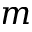<formula> <loc_0><loc_0><loc_500><loc_500>m</formula> 